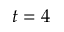Convert formula to latex. <formula><loc_0><loc_0><loc_500><loc_500>t = 4</formula> 